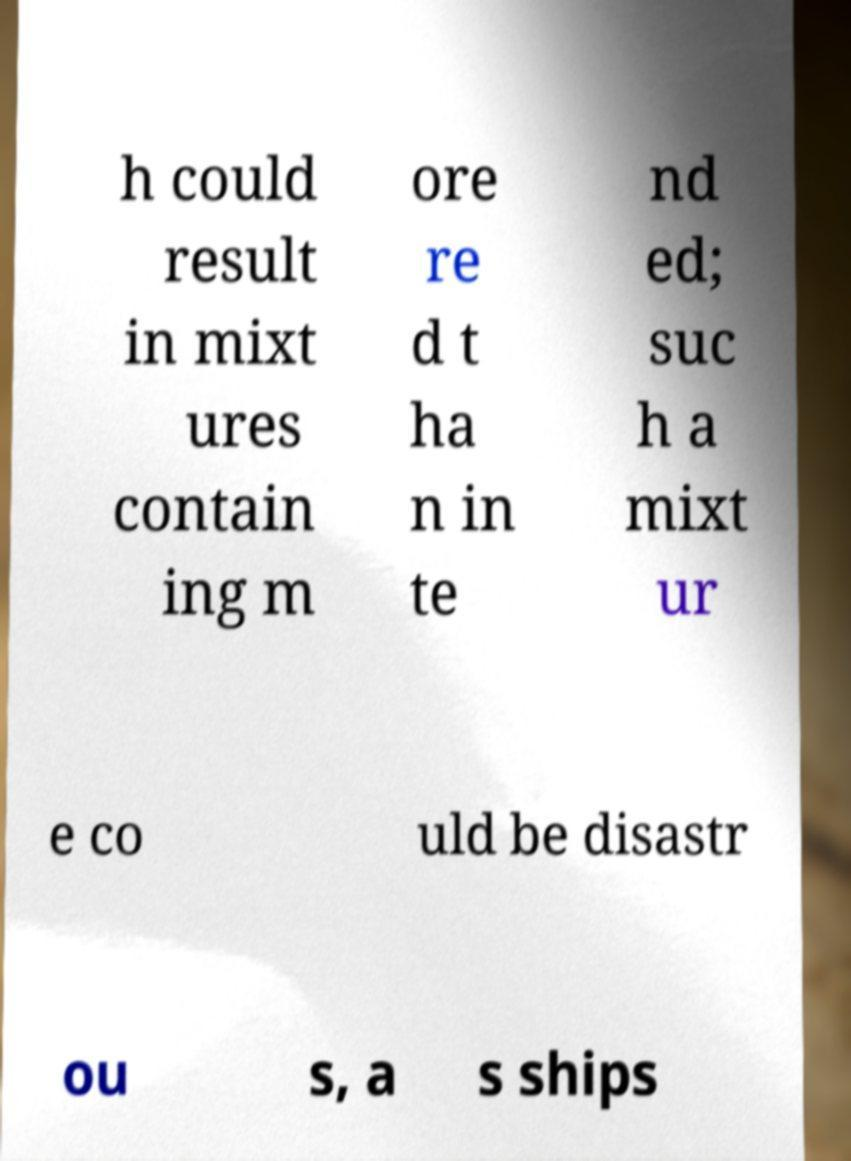I need the written content from this picture converted into text. Can you do that? h could result in mixt ures contain ing m ore re d t ha n in te nd ed; suc h a mixt ur e co uld be disastr ou s, a s ships 